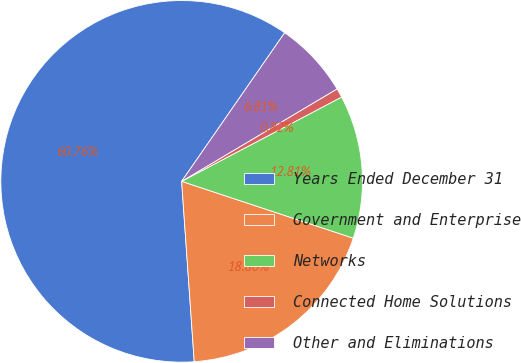<chart> <loc_0><loc_0><loc_500><loc_500><pie_chart><fcel>Years Ended December 31<fcel>Government and Enterprise<fcel>Networks<fcel>Connected Home Solutions<fcel>Other and Eliminations<nl><fcel>60.76%<fcel>18.8%<fcel>12.81%<fcel>0.82%<fcel>6.81%<nl></chart> 